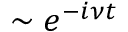<formula> <loc_0><loc_0><loc_500><loc_500>\sim e ^ { - i \nu t }</formula> 